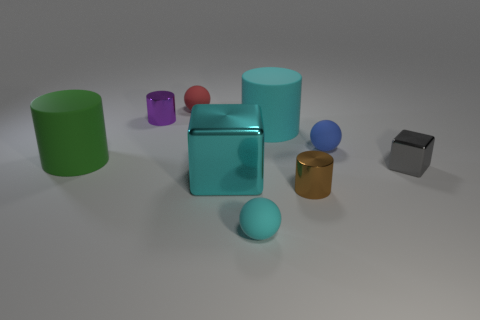Can you describe the lighting condition in this scene? The lighting in the scene appears to be diffused with shadows indicating a light source coming from the top left. The objects cast soft shadows on the ground, suggesting an even, possibly studio-like lighting setup. 